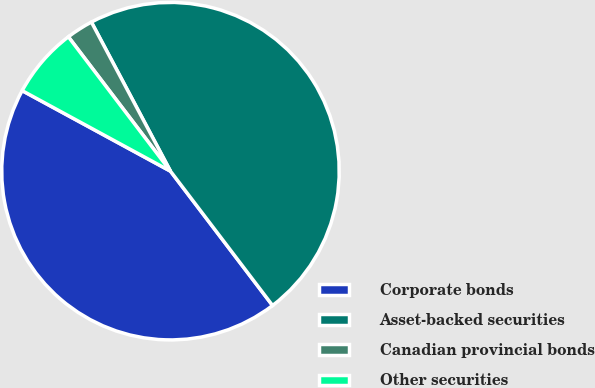Convert chart to OTSL. <chart><loc_0><loc_0><loc_500><loc_500><pie_chart><fcel>Corporate bonds<fcel>Asset-backed securities<fcel>Canadian provincial bonds<fcel>Other securities<nl><fcel>43.26%<fcel>47.42%<fcel>2.58%<fcel>6.74%<nl></chart> 